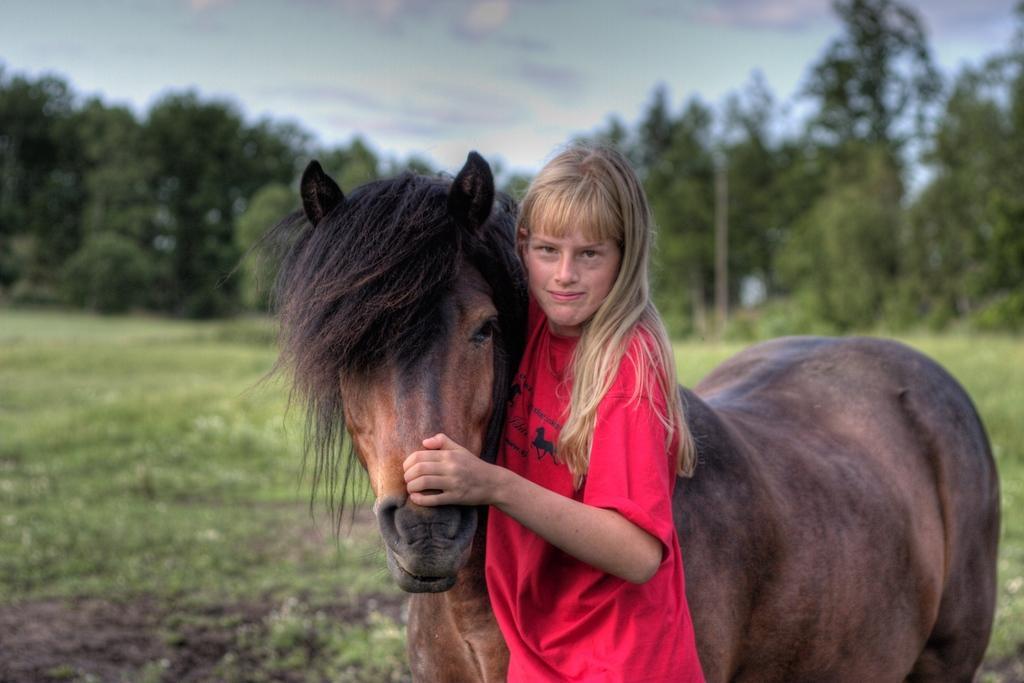Could you give a brief overview of what you see in this image? in this image i can see a person wearing red t shirt, is holding a horse. behind them there is grass and many trees 